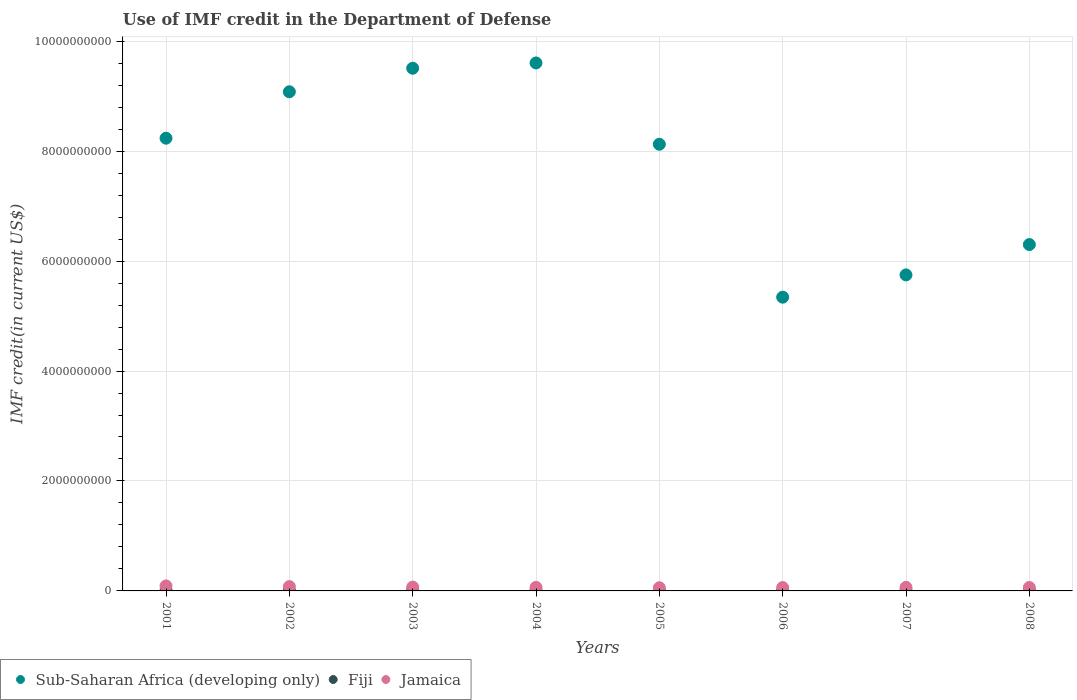Is the number of dotlines equal to the number of legend labels?
Give a very brief answer. Yes. What is the IMF credit in the Department of Defense in Fiji in 2007?
Keep it short and to the point. 1.10e+07. Across all years, what is the maximum IMF credit in the Department of Defense in Fiji?
Offer a very short reply. 1.10e+07. Across all years, what is the minimum IMF credit in the Department of Defense in Fiji?
Provide a short and direct response. 8.74e+06. In which year was the IMF credit in the Department of Defense in Fiji maximum?
Give a very brief answer. 2007. In which year was the IMF credit in the Department of Defense in Jamaica minimum?
Make the answer very short. 2005. What is the total IMF credit in the Department of Defense in Jamaica in the graph?
Provide a short and direct response. 5.49e+08. What is the difference between the IMF credit in the Department of Defense in Fiji in 2003 and that in 2007?
Provide a short and direct response. -6.56e+05. What is the difference between the IMF credit in the Department of Defense in Fiji in 2004 and the IMF credit in the Department of Defense in Jamaica in 2002?
Make the answer very short. -6.81e+07. What is the average IMF credit in the Department of Defense in Sub-Saharan Africa (developing only) per year?
Your answer should be compact. 7.74e+09. In the year 2004, what is the difference between the IMF credit in the Department of Defense in Fiji and IMF credit in the Department of Defense in Jamaica?
Give a very brief answer. -5.32e+07. In how many years, is the IMF credit in the Department of Defense in Sub-Saharan Africa (developing only) greater than 5600000000 US$?
Offer a terse response. 7. What is the ratio of the IMF credit in the Department of Defense in Jamaica in 2003 to that in 2006?
Offer a very short reply. 1.13. Is the IMF credit in the Department of Defense in Sub-Saharan Africa (developing only) in 2002 less than that in 2007?
Your response must be concise. No. Is the difference between the IMF credit in the Department of Defense in Fiji in 2004 and 2008 greater than the difference between the IMF credit in the Department of Defense in Jamaica in 2004 and 2008?
Your answer should be compact. No. What is the difference between the highest and the second highest IMF credit in the Department of Defense in Jamaica?
Make the answer very short. 1.22e+07. What is the difference between the highest and the lowest IMF credit in the Department of Defense in Jamaica?
Your response must be concise. 3.30e+07. In how many years, is the IMF credit in the Department of Defense in Fiji greater than the average IMF credit in the Department of Defense in Fiji taken over all years?
Your answer should be compact. 5. Does the IMF credit in the Department of Defense in Sub-Saharan Africa (developing only) monotonically increase over the years?
Your answer should be compact. No. Is the IMF credit in the Department of Defense in Fiji strictly greater than the IMF credit in the Department of Defense in Jamaica over the years?
Offer a terse response. No. Does the graph contain grids?
Make the answer very short. Yes. Where does the legend appear in the graph?
Keep it short and to the point. Bottom left. What is the title of the graph?
Ensure brevity in your answer.  Use of IMF credit in the Department of Defense. What is the label or title of the Y-axis?
Offer a very short reply. IMF credit(in current US$). What is the IMF credit(in current US$) of Sub-Saharan Africa (developing only) in 2001?
Your answer should be compact. 8.24e+09. What is the IMF credit(in current US$) of Fiji in 2001?
Your answer should be very brief. 8.74e+06. What is the IMF credit(in current US$) of Jamaica in 2001?
Offer a terse response. 9.11e+07. What is the IMF credit(in current US$) in Sub-Saharan Africa (developing only) in 2002?
Keep it short and to the point. 9.08e+09. What is the IMF credit(in current US$) of Fiji in 2002?
Your answer should be compact. 9.46e+06. What is the IMF credit(in current US$) of Jamaica in 2002?
Make the answer very short. 7.89e+07. What is the IMF credit(in current US$) of Sub-Saharan Africa (developing only) in 2003?
Make the answer very short. 9.51e+09. What is the IMF credit(in current US$) in Fiji in 2003?
Offer a terse response. 1.03e+07. What is the IMF credit(in current US$) of Jamaica in 2003?
Offer a very short reply. 6.92e+07. What is the IMF credit(in current US$) in Sub-Saharan Africa (developing only) in 2004?
Provide a succinct answer. 9.60e+09. What is the IMF credit(in current US$) of Fiji in 2004?
Keep it short and to the point. 1.08e+07. What is the IMF credit(in current US$) of Jamaica in 2004?
Provide a short and direct response. 6.40e+07. What is the IMF credit(in current US$) of Sub-Saharan Africa (developing only) in 2005?
Make the answer very short. 8.12e+09. What is the IMF credit(in current US$) in Fiji in 2005?
Provide a short and direct response. 9.94e+06. What is the IMF credit(in current US$) in Jamaica in 2005?
Keep it short and to the point. 5.80e+07. What is the IMF credit(in current US$) in Sub-Saharan Africa (developing only) in 2006?
Keep it short and to the point. 5.34e+09. What is the IMF credit(in current US$) in Fiji in 2006?
Make the answer very short. 1.05e+07. What is the IMF credit(in current US$) of Jamaica in 2006?
Make the answer very short. 6.11e+07. What is the IMF credit(in current US$) in Sub-Saharan Africa (developing only) in 2007?
Your response must be concise. 5.75e+09. What is the IMF credit(in current US$) of Fiji in 2007?
Provide a succinct answer. 1.10e+07. What is the IMF credit(in current US$) in Jamaica in 2007?
Your answer should be compact. 6.42e+07. What is the IMF credit(in current US$) of Sub-Saharan Africa (developing only) in 2008?
Your answer should be compact. 6.30e+09. What is the IMF credit(in current US$) of Fiji in 2008?
Offer a terse response. 1.07e+07. What is the IMF credit(in current US$) of Jamaica in 2008?
Provide a succinct answer. 6.26e+07. Across all years, what is the maximum IMF credit(in current US$) in Sub-Saharan Africa (developing only)?
Offer a terse response. 9.60e+09. Across all years, what is the maximum IMF credit(in current US$) in Fiji?
Give a very brief answer. 1.10e+07. Across all years, what is the maximum IMF credit(in current US$) in Jamaica?
Offer a very short reply. 9.11e+07. Across all years, what is the minimum IMF credit(in current US$) in Sub-Saharan Africa (developing only)?
Ensure brevity in your answer.  5.34e+09. Across all years, what is the minimum IMF credit(in current US$) of Fiji?
Your answer should be compact. 8.74e+06. Across all years, what is the minimum IMF credit(in current US$) of Jamaica?
Give a very brief answer. 5.80e+07. What is the total IMF credit(in current US$) of Sub-Saharan Africa (developing only) in the graph?
Make the answer very short. 6.19e+1. What is the total IMF credit(in current US$) of Fiji in the graph?
Your response must be concise. 8.15e+07. What is the total IMF credit(in current US$) in Jamaica in the graph?
Your answer should be very brief. 5.49e+08. What is the difference between the IMF credit(in current US$) in Sub-Saharan Africa (developing only) in 2001 and that in 2002?
Give a very brief answer. -8.44e+08. What is the difference between the IMF credit(in current US$) in Fiji in 2001 and that in 2002?
Keep it short and to the point. -7.16e+05. What is the difference between the IMF credit(in current US$) of Jamaica in 2001 and that in 2002?
Keep it short and to the point. 1.22e+07. What is the difference between the IMF credit(in current US$) of Sub-Saharan Africa (developing only) in 2001 and that in 2003?
Ensure brevity in your answer.  -1.27e+09. What is the difference between the IMF credit(in current US$) of Fiji in 2001 and that in 2003?
Provide a short and direct response. -1.60e+06. What is the difference between the IMF credit(in current US$) of Jamaica in 2001 and that in 2003?
Your response must be concise. 2.19e+07. What is the difference between the IMF credit(in current US$) of Sub-Saharan Africa (developing only) in 2001 and that in 2004?
Offer a terse response. -1.37e+09. What is the difference between the IMF credit(in current US$) of Fiji in 2001 and that in 2004?
Provide a short and direct response. -2.06e+06. What is the difference between the IMF credit(in current US$) of Jamaica in 2001 and that in 2004?
Keep it short and to the point. 2.71e+07. What is the difference between the IMF credit(in current US$) of Sub-Saharan Africa (developing only) in 2001 and that in 2005?
Give a very brief answer. 1.10e+08. What is the difference between the IMF credit(in current US$) in Fiji in 2001 and that in 2005?
Provide a short and direct response. -1.20e+06. What is the difference between the IMF credit(in current US$) in Jamaica in 2001 and that in 2005?
Keep it short and to the point. 3.30e+07. What is the difference between the IMF credit(in current US$) in Sub-Saharan Africa (developing only) in 2001 and that in 2006?
Your answer should be very brief. 2.89e+09. What is the difference between the IMF credit(in current US$) of Fiji in 2001 and that in 2006?
Make the answer very short. -1.72e+06. What is the difference between the IMF credit(in current US$) in Jamaica in 2001 and that in 2006?
Provide a short and direct response. 3.00e+07. What is the difference between the IMF credit(in current US$) of Sub-Saharan Africa (developing only) in 2001 and that in 2007?
Your response must be concise. 2.49e+09. What is the difference between the IMF credit(in current US$) of Fiji in 2001 and that in 2007?
Provide a short and direct response. -2.25e+06. What is the difference between the IMF credit(in current US$) of Jamaica in 2001 and that in 2007?
Your answer should be compact. 2.69e+07. What is the difference between the IMF credit(in current US$) in Sub-Saharan Africa (developing only) in 2001 and that in 2008?
Give a very brief answer. 1.93e+09. What is the difference between the IMF credit(in current US$) of Fiji in 2001 and that in 2008?
Offer a terse response. -1.97e+06. What is the difference between the IMF credit(in current US$) of Jamaica in 2001 and that in 2008?
Your response must be concise. 2.85e+07. What is the difference between the IMF credit(in current US$) of Sub-Saharan Africa (developing only) in 2002 and that in 2003?
Offer a very short reply. -4.28e+08. What is the difference between the IMF credit(in current US$) of Fiji in 2002 and that in 2003?
Give a very brief answer. -8.79e+05. What is the difference between the IMF credit(in current US$) in Jamaica in 2002 and that in 2003?
Your response must be concise. 9.64e+06. What is the difference between the IMF credit(in current US$) of Sub-Saharan Africa (developing only) in 2002 and that in 2004?
Make the answer very short. -5.25e+08. What is the difference between the IMF credit(in current US$) of Fiji in 2002 and that in 2004?
Offer a very short reply. -1.35e+06. What is the difference between the IMF credit(in current US$) of Jamaica in 2002 and that in 2004?
Provide a succinct answer. 1.49e+07. What is the difference between the IMF credit(in current US$) of Sub-Saharan Africa (developing only) in 2002 and that in 2005?
Give a very brief answer. 9.54e+08. What is the difference between the IMF credit(in current US$) in Fiji in 2002 and that in 2005?
Offer a terse response. -4.85e+05. What is the difference between the IMF credit(in current US$) in Jamaica in 2002 and that in 2005?
Provide a short and direct response. 2.08e+07. What is the difference between the IMF credit(in current US$) in Sub-Saharan Africa (developing only) in 2002 and that in 2006?
Provide a short and direct response. 3.74e+09. What is the difference between the IMF credit(in current US$) of Fiji in 2002 and that in 2006?
Offer a terse response. -1.01e+06. What is the difference between the IMF credit(in current US$) in Jamaica in 2002 and that in 2006?
Your answer should be very brief. 1.78e+07. What is the difference between the IMF credit(in current US$) in Sub-Saharan Africa (developing only) in 2002 and that in 2007?
Your answer should be very brief. 3.33e+09. What is the difference between the IMF credit(in current US$) of Fiji in 2002 and that in 2007?
Give a very brief answer. -1.54e+06. What is the difference between the IMF credit(in current US$) in Jamaica in 2002 and that in 2007?
Your answer should be compact. 1.47e+07. What is the difference between the IMF credit(in current US$) in Sub-Saharan Africa (developing only) in 2002 and that in 2008?
Provide a short and direct response. 2.78e+09. What is the difference between the IMF credit(in current US$) in Fiji in 2002 and that in 2008?
Your answer should be very brief. -1.26e+06. What is the difference between the IMF credit(in current US$) of Jamaica in 2002 and that in 2008?
Offer a very short reply. 1.63e+07. What is the difference between the IMF credit(in current US$) in Sub-Saharan Africa (developing only) in 2003 and that in 2004?
Offer a very short reply. -9.61e+07. What is the difference between the IMF credit(in current US$) of Fiji in 2003 and that in 2004?
Provide a short and direct response. -4.67e+05. What is the difference between the IMF credit(in current US$) of Jamaica in 2003 and that in 2004?
Offer a very short reply. 5.26e+06. What is the difference between the IMF credit(in current US$) in Sub-Saharan Africa (developing only) in 2003 and that in 2005?
Provide a short and direct response. 1.38e+09. What is the difference between the IMF credit(in current US$) of Fiji in 2003 and that in 2005?
Offer a terse response. 3.94e+05. What is the difference between the IMF credit(in current US$) in Jamaica in 2003 and that in 2005?
Your response must be concise. 1.12e+07. What is the difference between the IMF credit(in current US$) of Sub-Saharan Africa (developing only) in 2003 and that in 2006?
Give a very brief answer. 4.16e+09. What is the difference between the IMF credit(in current US$) of Fiji in 2003 and that in 2006?
Provide a succinct answer. -1.29e+05. What is the difference between the IMF credit(in current US$) in Jamaica in 2003 and that in 2006?
Ensure brevity in your answer.  8.14e+06. What is the difference between the IMF credit(in current US$) in Sub-Saharan Africa (developing only) in 2003 and that in 2007?
Make the answer very short. 3.76e+09. What is the difference between the IMF credit(in current US$) in Fiji in 2003 and that in 2007?
Keep it short and to the point. -6.56e+05. What is the difference between the IMF credit(in current US$) of Jamaica in 2003 and that in 2007?
Your response must be concise. 5.06e+06. What is the difference between the IMF credit(in current US$) in Sub-Saharan Africa (developing only) in 2003 and that in 2008?
Ensure brevity in your answer.  3.21e+09. What is the difference between the IMF credit(in current US$) in Fiji in 2003 and that in 2008?
Your answer should be compact. -3.78e+05. What is the difference between the IMF credit(in current US$) in Jamaica in 2003 and that in 2008?
Provide a succinct answer. 6.68e+06. What is the difference between the IMF credit(in current US$) of Sub-Saharan Africa (developing only) in 2004 and that in 2005?
Make the answer very short. 1.48e+09. What is the difference between the IMF credit(in current US$) in Fiji in 2004 and that in 2005?
Ensure brevity in your answer.  8.61e+05. What is the difference between the IMF credit(in current US$) in Jamaica in 2004 and that in 2005?
Provide a short and direct response. 5.93e+06. What is the difference between the IMF credit(in current US$) in Sub-Saharan Africa (developing only) in 2004 and that in 2006?
Your answer should be very brief. 4.26e+09. What is the difference between the IMF credit(in current US$) of Fiji in 2004 and that in 2006?
Offer a very short reply. 3.38e+05. What is the difference between the IMF credit(in current US$) in Jamaica in 2004 and that in 2006?
Keep it short and to the point. 2.88e+06. What is the difference between the IMF credit(in current US$) in Sub-Saharan Africa (developing only) in 2004 and that in 2007?
Give a very brief answer. 3.86e+09. What is the difference between the IMF credit(in current US$) in Fiji in 2004 and that in 2007?
Keep it short and to the point. -1.89e+05. What is the difference between the IMF credit(in current US$) in Jamaica in 2004 and that in 2007?
Provide a short and direct response. -2.02e+05. What is the difference between the IMF credit(in current US$) of Sub-Saharan Africa (developing only) in 2004 and that in 2008?
Make the answer very short. 3.30e+09. What is the difference between the IMF credit(in current US$) in Fiji in 2004 and that in 2008?
Your response must be concise. 8.90e+04. What is the difference between the IMF credit(in current US$) of Jamaica in 2004 and that in 2008?
Make the answer very short. 1.42e+06. What is the difference between the IMF credit(in current US$) in Sub-Saharan Africa (developing only) in 2005 and that in 2006?
Provide a succinct answer. 2.78e+09. What is the difference between the IMF credit(in current US$) in Fiji in 2005 and that in 2006?
Provide a short and direct response. -5.23e+05. What is the difference between the IMF credit(in current US$) of Jamaica in 2005 and that in 2006?
Your answer should be compact. -3.05e+06. What is the difference between the IMF credit(in current US$) of Sub-Saharan Africa (developing only) in 2005 and that in 2007?
Make the answer very short. 2.38e+09. What is the difference between the IMF credit(in current US$) of Fiji in 2005 and that in 2007?
Give a very brief answer. -1.05e+06. What is the difference between the IMF credit(in current US$) in Jamaica in 2005 and that in 2007?
Make the answer very short. -6.13e+06. What is the difference between the IMF credit(in current US$) in Sub-Saharan Africa (developing only) in 2005 and that in 2008?
Provide a succinct answer. 1.82e+09. What is the difference between the IMF credit(in current US$) of Fiji in 2005 and that in 2008?
Your response must be concise. -7.72e+05. What is the difference between the IMF credit(in current US$) of Jamaica in 2005 and that in 2008?
Make the answer very short. -4.51e+06. What is the difference between the IMF credit(in current US$) in Sub-Saharan Africa (developing only) in 2006 and that in 2007?
Your answer should be compact. -4.05e+08. What is the difference between the IMF credit(in current US$) of Fiji in 2006 and that in 2007?
Provide a short and direct response. -5.27e+05. What is the difference between the IMF credit(in current US$) of Jamaica in 2006 and that in 2007?
Your response must be concise. -3.08e+06. What is the difference between the IMF credit(in current US$) of Sub-Saharan Africa (developing only) in 2006 and that in 2008?
Your answer should be very brief. -9.57e+08. What is the difference between the IMF credit(in current US$) in Fiji in 2006 and that in 2008?
Keep it short and to the point. -2.49e+05. What is the difference between the IMF credit(in current US$) in Jamaica in 2006 and that in 2008?
Provide a short and direct response. -1.46e+06. What is the difference between the IMF credit(in current US$) in Sub-Saharan Africa (developing only) in 2007 and that in 2008?
Give a very brief answer. -5.52e+08. What is the difference between the IMF credit(in current US$) of Fiji in 2007 and that in 2008?
Make the answer very short. 2.78e+05. What is the difference between the IMF credit(in current US$) of Jamaica in 2007 and that in 2008?
Give a very brief answer. 1.62e+06. What is the difference between the IMF credit(in current US$) in Sub-Saharan Africa (developing only) in 2001 and the IMF credit(in current US$) in Fiji in 2002?
Provide a short and direct response. 8.23e+09. What is the difference between the IMF credit(in current US$) of Sub-Saharan Africa (developing only) in 2001 and the IMF credit(in current US$) of Jamaica in 2002?
Your response must be concise. 8.16e+09. What is the difference between the IMF credit(in current US$) in Fiji in 2001 and the IMF credit(in current US$) in Jamaica in 2002?
Offer a very short reply. -7.01e+07. What is the difference between the IMF credit(in current US$) in Sub-Saharan Africa (developing only) in 2001 and the IMF credit(in current US$) in Fiji in 2003?
Your answer should be compact. 8.22e+09. What is the difference between the IMF credit(in current US$) in Sub-Saharan Africa (developing only) in 2001 and the IMF credit(in current US$) in Jamaica in 2003?
Your answer should be compact. 8.17e+09. What is the difference between the IMF credit(in current US$) of Fiji in 2001 and the IMF credit(in current US$) of Jamaica in 2003?
Offer a very short reply. -6.05e+07. What is the difference between the IMF credit(in current US$) in Sub-Saharan Africa (developing only) in 2001 and the IMF credit(in current US$) in Fiji in 2004?
Ensure brevity in your answer.  8.22e+09. What is the difference between the IMF credit(in current US$) in Sub-Saharan Africa (developing only) in 2001 and the IMF credit(in current US$) in Jamaica in 2004?
Make the answer very short. 8.17e+09. What is the difference between the IMF credit(in current US$) of Fiji in 2001 and the IMF credit(in current US$) of Jamaica in 2004?
Give a very brief answer. -5.52e+07. What is the difference between the IMF credit(in current US$) in Sub-Saharan Africa (developing only) in 2001 and the IMF credit(in current US$) in Fiji in 2005?
Provide a succinct answer. 8.23e+09. What is the difference between the IMF credit(in current US$) in Sub-Saharan Africa (developing only) in 2001 and the IMF credit(in current US$) in Jamaica in 2005?
Offer a very short reply. 8.18e+09. What is the difference between the IMF credit(in current US$) in Fiji in 2001 and the IMF credit(in current US$) in Jamaica in 2005?
Keep it short and to the point. -4.93e+07. What is the difference between the IMF credit(in current US$) of Sub-Saharan Africa (developing only) in 2001 and the IMF credit(in current US$) of Fiji in 2006?
Make the answer very short. 8.22e+09. What is the difference between the IMF credit(in current US$) in Sub-Saharan Africa (developing only) in 2001 and the IMF credit(in current US$) in Jamaica in 2006?
Make the answer very short. 8.17e+09. What is the difference between the IMF credit(in current US$) in Fiji in 2001 and the IMF credit(in current US$) in Jamaica in 2006?
Offer a very short reply. -5.24e+07. What is the difference between the IMF credit(in current US$) of Sub-Saharan Africa (developing only) in 2001 and the IMF credit(in current US$) of Fiji in 2007?
Your answer should be very brief. 8.22e+09. What is the difference between the IMF credit(in current US$) of Sub-Saharan Africa (developing only) in 2001 and the IMF credit(in current US$) of Jamaica in 2007?
Your answer should be compact. 8.17e+09. What is the difference between the IMF credit(in current US$) in Fiji in 2001 and the IMF credit(in current US$) in Jamaica in 2007?
Your response must be concise. -5.54e+07. What is the difference between the IMF credit(in current US$) in Sub-Saharan Africa (developing only) in 2001 and the IMF credit(in current US$) in Fiji in 2008?
Provide a succinct answer. 8.22e+09. What is the difference between the IMF credit(in current US$) in Sub-Saharan Africa (developing only) in 2001 and the IMF credit(in current US$) in Jamaica in 2008?
Your answer should be compact. 8.17e+09. What is the difference between the IMF credit(in current US$) of Fiji in 2001 and the IMF credit(in current US$) of Jamaica in 2008?
Offer a very short reply. -5.38e+07. What is the difference between the IMF credit(in current US$) of Sub-Saharan Africa (developing only) in 2002 and the IMF credit(in current US$) of Fiji in 2003?
Offer a very short reply. 9.07e+09. What is the difference between the IMF credit(in current US$) of Sub-Saharan Africa (developing only) in 2002 and the IMF credit(in current US$) of Jamaica in 2003?
Your answer should be very brief. 9.01e+09. What is the difference between the IMF credit(in current US$) in Fiji in 2002 and the IMF credit(in current US$) in Jamaica in 2003?
Provide a succinct answer. -5.98e+07. What is the difference between the IMF credit(in current US$) in Sub-Saharan Africa (developing only) in 2002 and the IMF credit(in current US$) in Fiji in 2004?
Your answer should be very brief. 9.07e+09. What is the difference between the IMF credit(in current US$) in Sub-Saharan Africa (developing only) in 2002 and the IMF credit(in current US$) in Jamaica in 2004?
Ensure brevity in your answer.  9.02e+09. What is the difference between the IMF credit(in current US$) of Fiji in 2002 and the IMF credit(in current US$) of Jamaica in 2004?
Provide a short and direct response. -5.45e+07. What is the difference between the IMF credit(in current US$) in Sub-Saharan Africa (developing only) in 2002 and the IMF credit(in current US$) in Fiji in 2005?
Your answer should be compact. 9.07e+09. What is the difference between the IMF credit(in current US$) in Sub-Saharan Africa (developing only) in 2002 and the IMF credit(in current US$) in Jamaica in 2005?
Provide a short and direct response. 9.02e+09. What is the difference between the IMF credit(in current US$) of Fiji in 2002 and the IMF credit(in current US$) of Jamaica in 2005?
Your answer should be compact. -4.86e+07. What is the difference between the IMF credit(in current US$) of Sub-Saharan Africa (developing only) in 2002 and the IMF credit(in current US$) of Fiji in 2006?
Your response must be concise. 9.07e+09. What is the difference between the IMF credit(in current US$) in Sub-Saharan Africa (developing only) in 2002 and the IMF credit(in current US$) in Jamaica in 2006?
Give a very brief answer. 9.02e+09. What is the difference between the IMF credit(in current US$) of Fiji in 2002 and the IMF credit(in current US$) of Jamaica in 2006?
Provide a short and direct response. -5.16e+07. What is the difference between the IMF credit(in current US$) of Sub-Saharan Africa (developing only) in 2002 and the IMF credit(in current US$) of Fiji in 2007?
Your response must be concise. 9.07e+09. What is the difference between the IMF credit(in current US$) of Sub-Saharan Africa (developing only) in 2002 and the IMF credit(in current US$) of Jamaica in 2007?
Provide a short and direct response. 9.02e+09. What is the difference between the IMF credit(in current US$) of Fiji in 2002 and the IMF credit(in current US$) of Jamaica in 2007?
Offer a very short reply. -5.47e+07. What is the difference between the IMF credit(in current US$) of Sub-Saharan Africa (developing only) in 2002 and the IMF credit(in current US$) of Fiji in 2008?
Your answer should be very brief. 9.07e+09. What is the difference between the IMF credit(in current US$) in Sub-Saharan Africa (developing only) in 2002 and the IMF credit(in current US$) in Jamaica in 2008?
Make the answer very short. 9.02e+09. What is the difference between the IMF credit(in current US$) in Fiji in 2002 and the IMF credit(in current US$) in Jamaica in 2008?
Your answer should be compact. -5.31e+07. What is the difference between the IMF credit(in current US$) in Sub-Saharan Africa (developing only) in 2003 and the IMF credit(in current US$) in Fiji in 2004?
Make the answer very short. 9.50e+09. What is the difference between the IMF credit(in current US$) of Sub-Saharan Africa (developing only) in 2003 and the IMF credit(in current US$) of Jamaica in 2004?
Your answer should be very brief. 9.44e+09. What is the difference between the IMF credit(in current US$) in Fiji in 2003 and the IMF credit(in current US$) in Jamaica in 2004?
Your response must be concise. -5.36e+07. What is the difference between the IMF credit(in current US$) in Sub-Saharan Africa (developing only) in 2003 and the IMF credit(in current US$) in Fiji in 2005?
Offer a very short reply. 9.50e+09. What is the difference between the IMF credit(in current US$) in Sub-Saharan Africa (developing only) in 2003 and the IMF credit(in current US$) in Jamaica in 2005?
Your response must be concise. 9.45e+09. What is the difference between the IMF credit(in current US$) of Fiji in 2003 and the IMF credit(in current US$) of Jamaica in 2005?
Keep it short and to the point. -4.77e+07. What is the difference between the IMF credit(in current US$) of Sub-Saharan Africa (developing only) in 2003 and the IMF credit(in current US$) of Fiji in 2006?
Give a very brief answer. 9.50e+09. What is the difference between the IMF credit(in current US$) in Sub-Saharan Africa (developing only) in 2003 and the IMF credit(in current US$) in Jamaica in 2006?
Your answer should be very brief. 9.45e+09. What is the difference between the IMF credit(in current US$) of Fiji in 2003 and the IMF credit(in current US$) of Jamaica in 2006?
Ensure brevity in your answer.  -5.08e+07. What is the difference between the IMF credit(in current US$) in Sub-Saharan Africa (developing only) in 2003 and the IMF credit(in current US$) in Fiji in 2007?
Your response must be concise. 9.50e+09. What is the difference between the IMF credit(in current US$) of Sub-Saharan Africa (developing only) in 2003 and the IMF credit(in current US$) of Jamaica in 2007?
Your answer should be very brief. 9.44e+09. What is the difference between the IMF credit(in current US$) in Fiji in 2003 and the IMF credit(in current US$) in Jamaica in 2007?
Ensure brevity in your answer.  -5.38e+07. What is the difference between the IMF credit(in current US$) in Sub-Saharan Africa (developing only) in 2003 and the IMF credit(in current US$) in Fiji in 2008?
Provide a succinct answer. 9.50e+09. What is the difference between the IMF credit(in current US$) in Sub-Saharan Africa (developing only) in 2003 and the IMF credit(in current US$) in Jamaica in 2008?
Provide a short and direct response. 9.45e+09. What is the difference between the IMF credit(in current US$) in Fiji in 2003 and the IMF credit(in current US$) in Jamaica in 2008?
Your answer should be very brief. -5.22e+07. What is the difference between the IMF credit(in current US$) in Sub-Saharan Africa (developing only) in 2004 and the IMF credit(in current US$) in Fiji in 2005?
Make the answer very short. 9.59e+09. What is the difference between the IMF credit(in current US$) of Sub-Saharan Africa (developing only) in 2004 and the IMF credit(in current US$) of Jamaica in 2005?
Give a very brief answer. 9.55e+09. What is the difference between the IMF credit(in current US$) of Fiji in 2004 and the IMF credit(in current US$) of Jamaica in 2005?
Provide a succinct answer. -4.72e+07. What is the difference between the IMF credit(in current US$) of Sub-Saharan Africa (developing only) in 2004 and the IMF credit(in current US$) of Fiji in 2006?
Keep it short and to the point. 9.59e+09. What is the difference between the IMF credit(in current US$) in Sub-Saharan Africa (developing only) in 2004 and the IMF credit(in current US$) in Jamaica in 2006?
Your answer should be compact. 9.54e+09. What is the difference between the IMF credit(in current US$) of Fiji in 2004 and the IMF credit(in current US$) of Jamaica in 2006?
Your response must be concise. -5.03e+07. What is the difference between the IMF credit(in current US$) in Sub-Saharan Africa (developing only) in 2004 and the IMF credit(in current US$) in Fiji in 2007?
Ensure brevity in your answer.  9.59e+09. What is the difference between the IMF credit(in current US$) in Sub-Saharan Africa (developing only) in 2004 and the IMF credit(in current US$) in Jamaica in 2007?
Ensure brevity in your answer.  9.54e+09. What is the difference between the IMF credit(in current US$) of Fiji in 2004 and the IMF credit(in current US$) of Jamaica in 2007?
Make the answer very short. -5.34e+07. What is the difference between the IMF credit(in current US$) of Sub-Saharan Africa (developing only) in 2004 and the IMF credit(in current US$) of Fiji in 2008?
Provide a succinct answer. 9.59e+09. What is the difference between the IMF credit(in current US$) of Sub-Saharan Africa (developing only) in 2004 and the IMF credit(in current US$) of Jamaica in 2008?
Give a very brief answer. 9.54e+09. What is the difference between the IMF credit(in current US$) in Fiji in 2004 and the IMF credit(in current US$) in Jamaica in 2008?
Make the answer very short. -5.17e+07. What is the difference between the IMF credit(in current US$) of Sub-Saharan Africa (developing only) in 2005 and the IMF credit(in current US$) of Fiji in 2006?
Offer a very short reply. 8.11e+09. What is the difference between the IMF credit(in current US$) in Sub-Saharan Africa (developing only) in 2005 and the IMF credit(in current US$) in Jamaica in 2006?
Keep it short and to the point. 8.06e+09. What is the difference between the IMF credit(in current US$) in Fiji in 2005 and the IMF credit(in current US$) in Jamaica in 2006?
Make the answer very short. -5.12e+07. What is the difference between the IMF credit(in current US$) of Sub-Saharan Africa (developing only) in 2005 and the IMF credit(in current US$) of Fiji in 2007?
Keep it short and to the point. 8.11e+09. What is the difference between the IMF credit(in current US$) in Sub-Saharan Africa (developing only) in 2005 and the IMF credit(in current US$) in Jamaica in 2007?
Provide a short and direct response. 8.06e+09. What is the difference between the IMF credit(in current US$) of Fiji in 2005 and the IMF credit(in current US$) of Jamaica in 2007?
Offer a terse response. -5.42e+07. What is the difference between the IMF credit(in current US$) of Sub-Saharan Africa (developing only) in 2005 and the IMF credit(in current US$) of Fiji in 2008?
Your answer should be very brief. 8.11e+09. What is the difference between the IMF credit(in current US$) of Sub-Saharan Africa (developing only) in 2005 and the IMF credit(in current US$) of Jamaica in 2008?
Provide a succinct answer. 8.06e+09. What is the difference between the IMF credit(in current US$) of Fiji in 2005 and the IMF credit(in current US$) of Jamaica in 2008?
Give a very brief answer. -5.26e+07. What is the difference between the IMF credit(in current US$) of Sub-Saharan Africa (developing only) in 2006 and the IMF credit(in current US$) of Fiji in 2007?
Provide a short and direct response. 5.33e+09. What is the difference between the IMF credit(in current US$) of Sub-Saharan Africa (developing only) in 2006 and the IMF credit(in current US$) of Jamaica in 2007?
Offer a terse response. 5.28e+09. What is the difference between the IMF credit(in current US$) of Fiji in 2006 and the IMF credit(in current US$) of Jamaica in 2007?
Your answer should be very brief. -5.37e+07. What is the difference between the IMF credit(in current US$) of Sub-Saharan Africa (developing only) in 2006 and the IMF credit(in current US$) of Fiji in 2008?
Provide a succinct answer. 5.33e+09. What is the difference between the IMF credit(in current US$) of Sub-Saharan Africa (developing only) in 2006 and the IMF credit(in current US$) of Jamaica in 2008?
Offer a very short reply. 5.28e+09. What is the difference between the IMF credit(in current US$) in Fiji in 2006 and the IMF credit(in current US$) in Jamaica in 2008?
Provide a succinct answer. -5.21e+07. What is the difference between the IMF credit(in current US$) in Sub-Saharan Africa (developing only) in 2007 and the IMF credit(in current US$) in Fiji in 2008?
Ensure brevity in your answer.  5.74e+09. What is the difference between the IMF credit(in current US$) in Sub-Saharan Africa (developing only) in 2007 and the IMF credit(in current US$) in Jamaica in 2008?
Offer a terse response. 5.69e+09. What is the difference between the IMF credit(in current US$) in Fiji in 2007 and the IMF credit(in current US$) in Jamaica in 2008?
Ensure brevity in your answer.  -5.16e+07. What is the average IMF credit(in current US$) in Sub-Saharan Africa (developing only) per year?
Ensure brevity in your answer.  7.74e+09. What is the average IMF credit(in current US$) of Fiji per year?
Your answer should be very brief. 1.02e+07. What is the average IMF credit(in current US$) in Jamaica per year?
Provide a short and direct response. 6.86e+07. In the year 2001, what is the difference between the IMF credit(in current US$) in Sub-Saharan Africa (developing only) and IMF credit(in current US$) in Fiji?
Keep it short and to the point. 8.23e+09. In the year 2001, what is the difference between the IMF credit(in current US$) in Sub-Saharan Africa (developing only) and IMF credit(in current US$) in Jamaica?
Provide a succinct answer. 8.14e+09. In the year 2001, what is the difference between the IMF credit(in current US$) in Fiji and IMF credit(in current US$) in Jamaica?
Offer a very short reply. -8.23e+07. In the year 2002, what is the difference between the IMF credit(in current US$) of Sub-Saharan Africa (developing only) and IMF credit(in current US$) of Fiji?
Ensure brevity in your answer.  9.07e+09. In the year 2002, what is the difference between the IMF credit(in current US$) in Sub-Saharan Africa (developing only) and IMF credit(in current US$) in Jamaica?
Make the answer very short. 9.00e+09. In the year 2002, what is the difference between the IMF credit(in current US$) of Fiji and IMF credit(in current US$) of Jamaica?
Provide a succinct answer. -6.94e+07. In the year 2003, what is the difference between the IMF credit(in current US$) in Sub-Saharan Africa (developing only) and IMF credit(in current US$) in Fiji?
Your answer should be very brief. 9.50e+09. In the year 2003, what is the difference between the IMF credit(in current US$) of Sub-Saharan Africa (developing only) and IMF credit(in current US$) of Jamaica?
Provide a succinct answer. 9.44e+09. In the year 2003, what is the difference between the IMF credit(in current US$) of Fiji and IMF credit(in current US$) of Jamaica?
Your answer should be compact. -5.89e+07. In the year 2004, what is the difference between the IMF credit(in current US$) in Sub-Saharan Africa (developing only) and IMF credit(in current US$) in Fiji?
Your answer should be compact. 9.59e+09. In the year 2004, what is the difference between the IMF credit(in current US$) of Sub-Saharan Africa (developing only) and IMF credit(in current US$) of Jamaica?
Your answer should be very brief. 9.54e+09. In the year 2004, what is the difference between the IMF credit(in current US$) in Fiji and IMF credit(in current US$) in Jamaica?
Provide a short and direct response. -5.32e+07. In the year 2005, what is the difference between the IMF credit(in current US$) in Sub-Saharan Africa (developing only) and IMF credit(in current US$) in Fiji?
Your answer should be compact. 8.11e+09. In the year 2005, what is the difference between the IMF credit(in current US$) in Sub-Saharan Africa (developing only) and IMF credit(in current US$) in Jamaica?
Keep it short and to the point. 8.07e+09. In the year 2005, what is the difference between the IMF credit(in current US$) of Fiji and IMF credit(in current US$) of Jamaica?
Give a very brief answer. -4.81e+07. In the year 2006, what is the difference between the IMF credit(in current US$) of Sub-Saharan Africa (developing only) and IMF credit(in current US$) of Fiji?
Your response must be concise. 5.33e+09. In the year 2006, what is the difference between the IMF credit(in current US$) in Sub-Saharan Africa (developing only) and IMF credit(in current US$) in Jamaica?
Your answer should be compact. 5.28e+09. In the year 2006, what is the difference between the IMF credit(in current US$) of Fiji and IMF credit(in current US$) of Jamaica?
Your answer should be compact. -5.06e+07. In the year 2007, what is the difference between the IMF credit(in current US$) in Sub-Saharan Africa (developing only) and IMF credit(in current US$) in Fiji?
Your answer should be compact. 5.74e+09. In the year 2007, what is the difference between the IMF credit(in current US$) of Sub-Saharan Africa (developing only) and IMF credit(in current US$) of Jamaica?
Provide a short and direct response. 5.68e+09. In the year 2007, what is the difference between the IMF credit(in current US$) of Fiji and IMF credit(in current US$) of Jamaica?
Provide a short and direct response. -5.32e+07. In the year 2008, what is the difference between the IMF credit(in current US$) of Sub-Saharan Africa (developing only) and IMF credit(in current US$) of Fiji?
Keep it short and to the point. 6.29e+09. In the year 2008, what is the difference between the IMF credit(in current US$) in Sub-Saharan Africa (developing only) and IMF credit(in current US$) in Jamaica?
Ensure brevity in your answer.  6.24e+09. In the year 2008, what is the difference between the IMF credit(in current US$) of Fiji and IMF credit(in current US$) of Jamaica?
Your response must be concise. -5.18e+07. What is the ratio of the IMF credit(in current US$) of Sub-Saharan Africa (developing only) in 2001 to that in 2002?
Make the answer very short. 0.91. What is the ratio of the IMF credit(in current US$) in Fiji in 2001 to that in 2002?
Ensure brevity in your answer.  0.92. What is the ratio of the IMF credit(in current US$) of Jamaica in 2001 to that in 2002?
Provide a short and direct response. 1.15. What is the ratio of the IMF credit(in current US$) in Sub-Saharan Africa (developing only) in 2001 to that in 2003?
Your answer should be very brief. 0.87. What is the ratio of the IMF credit(in current US$) in Fiji in 2001 to that in 2003?
Keep it short and to the point. 0.85. What is the ratio of the IMF credit(in current US$) in Jamaica in 2001 to that in 2003?
Offer a terse response. 1.32. What is the ratio of the IMF credit(in current US$) of Sub-Saharan Africa (developing only) in 2001 to that in 2004?
Keep it short and to the point. 0.86. What is the ratio of the IMF credit(in current US$) of Fiji in 2001 to that in 2004?
Offer a terse response. 0.81. What is the ratio of the IMF credit(in current US$) in Jamaica in 2001 to that in 2004?
Keep it short and to the point. 1.42. What is the ratio of the IMF credit(in current US$) in Sub-Saharan Africa (developing only) in 2001 to that in 2005?
Provide a short and direct response. 1.01. What is the ratio of the IMF credit(in current US$) in Fiji in 2001 to that in 2005?
Your answer should be very brief. 0.88. What is the ratio of the IMF credit(in current US$) in Jamaica in 2001 to that in 2005?
Offer a terse response. 1.57. What is the ratio of the IMF credit(in current US$) of Sub-Saharan Africa (developing only) in 2001 to that in 2006?
Provide a succinct answer. 1.54. What is the ratio of the IMF credit(in current US$) in Fiji in 2001 to that in 2006?
Give a very brief answer. 0.84. What is the ratio of the IMF credit(in current US$) of Jamaica in 2001 to that in 2006?
Your answer should be very brief. 1.49. What is the ratio of the IMF credit(in current US$) of Sub-Saharan Africa (developing only) in 2001 to that in 2007?
Make the answer very short. 1.43. What is the ratio of the IMF credit(in current US$) of Fiji in 2001 to that in 2007?
Ensure brevity in your answer.  0.8. What is the ratio of the IMF credit(in current US$) in Jamaica in 2001 to that in 2007?
Provide a short and direct response. 1.42. What is the ratio of the IMF credit(in current US$) of Sub-Saharan Africa (developing only) in 2001 to that in 2008?
Ensure brevity in your answer.  1.31. What is the ratio of the IMF credit(in current US$) in Fiji in 2001 to that in 2008?
Offer a terse response. 0.82. What is the ratio of the IMF credit(in current US$) in Jamaica in 2001 to that in 2008?
Keep it short and to the point. 1.46. What is the ratio of the IMF credit(in current US$) of Sub-Saharan Africa (developing only) in 2002 to that in 2003?
Keep it short and to the point. 0.95. What is the ratio of the IMF credit(in current US$) of Fiji in 2002 to that in 2003?
Offer a very short reply. 0.92. What is the ratio of the IMF credit(in current US$) in Jamaica in 2002 to that in 2003?
Your response must be concise. 1.14. What is the ratio of the IMF credit(in current US$) in Sub-Saharan Africa (developing only) in 2002 to that in 2004?
Offer a terse response. 0.95. What is the ratio of the IMF credit(in current US$) of Fiji in 2002 to that in 2004?
Offer a very short reply. 0.88. What is the ratio of the IMF credit(in current US$) of Jamaica in 2002 to that in 2004?
Your answer should be very brief. 1.23. What is the ratio of the IMF credit(in current US$) of Sub-Saharan Africa (developing only) in 2002 to that in 2005?
Your answer should be very brief. 1.12. What is the ratio of the IMF credit(in current US$) in Fiji in 2002 to that in 2005?
Provide a succinct answer. 0.95. What is the ratio of the IMF credit(in current US$) in Jamaica in 2002 to that in 2005?
Provide a succinct answer. 1.36. What is the ratio of the IMF credit(in current US$) in Sub-Saharan Africa (developing only) in 2002 to that in 2006?
Your response must be concise. 1.7. What is the ratio of the IMF credit(in current US$) of Fiji in 2002 to that in 2006?
Provide a short and direct response. 0.9. What is the ratio of the IMF credit(in current US$) in Jamaica in 2002 to that in 2006?
Your response must be concise. 1.29. What is the ratio of the IMF credit(in current US$) in Sub-Saharan Africa (developing only) in 2002 to that in 2007?
Keep it short and to the point. 1.58. What is the ratio of the IMF credit(in current US$) of Fiji in 2002 to that in 2007?
Your response must be concise. 0.86. What is the ratio of the IMF credit(in current US$) of Jamaica in 2002 to that in 2007?
Give a very brief answer. 1.23. What is the ratio of the IMF credit(in current US$) in Sub-Saharan Africa (developing only) in 2002 to that in 2008?
Offer a terse response. 1.44. What is the ratio of the IMF credit(in current US$) in Fiji in 2002 to that in 2008?
Your answer should be compact. 0.88. What is the ratio of the IMF credit(in current US$) of Jamaica in 2002 to that in 2008?
Offer a terse response. 1.26. What is the ratio of the IMF credit(in current US$) of Sub-Saharan Africa (developing only) in 2003 to that in 2004?
Keep it short and to the point. 0.99. What is the ratio of the IMF credit(in current US$) of Fiji in 2003 to that in 2004?
Your answer should be compact. 0.96. What is the ratio of the IMF credit(in current US$) in Jamaica in 2003 to that in 2004?
Make the answer very short. 1.08. What is the ratio of the IMF credit(in current US$) in Sub-Saharan Africa (developing only) in 2003 to that in 2005?
Your answer should be compact. 1.17. What is the ratio of the IMF credit(in current US$) in Fiji in 2003 to that in 2005?
Offer a terse response. 1.04. What is the ratio of the IMF credit(in current US$) in Jamaica in 2003 to that in 2005?
Offer a terse response. 1.19. What is the ratio of the IMF credit(in current US$) in Sub-Saharan Africa (developing only) in 2003 to that in 2006?
Ensure brevity in your answer.  1.78. What is the ratio of the IMF credit(in current US$) of Fiji in 2003 to that in 2006?
Keep it short and to the point. 0.99. What is the ratio of the IMF credit(in current US$) in Jamaica in 2003 to that in 2006?
Keep it short and to the point. 1.13. What is the ratio of the IMF credit(in current US$) of Sub-Saharan Africa (developing only) in 2003 to that in 2007?
Your answer should be very brief. 1.65. What is the ratio of the IMF credit(in current US$) of Fiji in 2003 to that in 2007?
Your response must be concise. 0.94. What is the ratio of the IMF credit(in current US$) of Jamaica in 2003 to that in 2007?
Ensure brevity in your answer.  1.08. What is the ratio of the IMF credit(in current US$) in Sub-Saharan Africa (developing only) in 2003 to that in 2008?
Provide a succinct answer. 1.51. What is the ratio of the IMF credit(in current US$) in Fiji in 2003 to that in 2008?
Provide a short and direct response. 0.96. What is the ratio of the IMF credit(in current US$) of Jamaica in 2003 to that in 2008?
Your answer should be compact. 1.11. What is the ratio of the IMF credit(in current US$) of Sub-Saharan Africa (developing only) in 2004 to that in 2005?
Ensure brevity in your answer.  1.18. What is the ratio of the IMF credit(in current US$) in Fiji in 2004 to that in 2005?
Give a very brief answer. 1.09. What is the ratio of the IMF credit(in current US$) of Jamaica in 2004 to that in 2005?
Offer a terse response. 1.1. What is the ratio of the IMF credit(in current US$) in Sub-Saharan Africa (developing only) in 2004 to that in 2006?
Make the answer very short. 1.8. What is the ratio of the IMF credit(in current US$) in Fiji in 2004 to that in 2006?
Your response must be concise. 1.03. What is the ratio of the IMF credit(in current US$) in Jamaica in 2004 to that in 2006?
Give a very brief answer. 1.05. What is the ratio of the IMF credit(in current US$) of Sub-Saharan Africa (developing only) in 2004 to that in 2007?
Your answer should be very brief. 1.67. What is the ratio of the IMF credit(in current US$) of Fiji in 2004 to that in 2007?
Offer a terse response. 0.98. What is the ratio of the IMF credit(in current US$) in Sub-Saharan Africa (developing only) in 2004 to that in 2008?
Offer a very short reply. 1.52. What is the ratio of the IMF credit(in current US$) of Fiji in 2004 to that in 2008?
Provide a short and direct response. 1.01. What is the ratio of the IMF credit(in current US$) in Jamaica in 2004 to that in 2008?
Give a very brief answer. 1.02. What is the ratio of the IMF credit(in current US$) of Sub-Saharan Africa (developing only) in 2005 to that in 2006?
Provide a succinct answer. 1.52. What is the ratio of the IMF credit(in current US$) in Fiji in 2005 to that in 2006?
Ensure brevity in your answer.  0.95. What is the ratio of the IMF credit(in current US$) of Jamaica in 2005 to that in 2006?
Your answer should be compact. 0.95. What is the ratio of the IMF credit(in current US$) of Sub-Saharan Africa (developing only) in 2005 to that in 2007?
Your answer should be compact. 1.41. What is the ratio of the IMF credit(in current US$) of Fiji in 2005 to that in 2007?
Make the answer very short. 0.9. What is the ratio of the IMF credit(in current US$) in Jamaica in 2005 to that in 2007?
Keep it short and to the point. 0.9. What is the ratio of the IMF credit(in current US$) of Sub-Saharan Africa (developing only) in 2005 to that in 2008?
Provide a succinct answer. 1.29. What is the ratio of the IMF credit(in current US$) in Fiji in 2005 to that in 2008?
Your response must be concise. 0.93. What is the ratio of the IMF credit(in current US$) in Jamaica in 2005 to that in 2008?
Your answer should be very brief. 0.93. What is the ratio of the IMF credit(in current US$) in Sub-Saharan Africa (developing only) in 2006 to that in 2007?
Give a very brief answer. 0.93. What is the ratio of the IMF credit(in current US$) of Fiji in 2006 to that in 2007?
Your answer should be very brief. 0.95. What is the ratio of the IMF credit(in current US$) of Sub-Saharan Africa (developing only) in 2006 to that in 2008?
Your response must be concise. 0.85. What is the ratio of the IMF credit(in current US$) of Fiji in 2006 to that in 2008?
Offer a very short reply. 0.98. What is the ratio of the IMF credit(in current US$) in Jamaica in 2006 to that in 2008?
Your answer should be very brief. 0.98. What is the ratio of the IMF credit(in current US$) of Sub-Saharan Africa (developing only) in 2007 to that in 2008?
Your answer should be very brief. 0.91. What is the ratio of the IMF credit(in current US$) in Fiji in 2007 to that in 2008?
Provide a short and direct response. 1.03. What is the ratio of the IMF credit(in current US$) of Jamaica in 2007 to that in 2008?
Offer a very short reply. 1.03. What is the difference between the highest and the second highest IMF credit(in current US$) in Sub-Saharan Africa (developing only)?
Your response must be concise. 9.61e+07. What is the difference between the highest and the second highest IMF credit(in current US$) in Fiji?
Your answer should be compact. 1.89e+05. What is the difference between the highest and the second highest IMF credit(in current US$) of Jamaica?
Ensure brevity in your answer.  1.22e+07. What is the difference between the highest and the lowest IMF credit(in current US$) of Sub-Saharan Africa (developing only)?
Your answer should be compact. 4.26e+09. What is the difference between the highest and the lowest IMF credit(in current US$) in Fiji?
Your response must be concise. 2.25e+06. What is the difference between the highest and the lowest IMF credit(in current US$) in Jamaica?
Keep it short and to the point. 3.30e+07. 